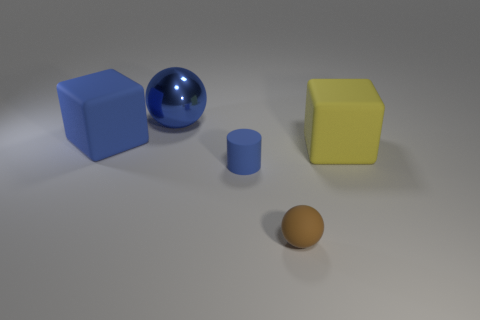Add 3 small blue rubber cylinders. How many objects exist? 8 Subtract all cubes. How many objects are left? 3 Subtract all cyan metal things. Subtract all big blue metal balls. How many objects are left? 4 Add 4 yellow things. How many yellow things are left? 5 Add 3 big metal cylinders. How many big metal cylinders exist? 3 Subtract 0 green cubes. How many objects are left? 5 